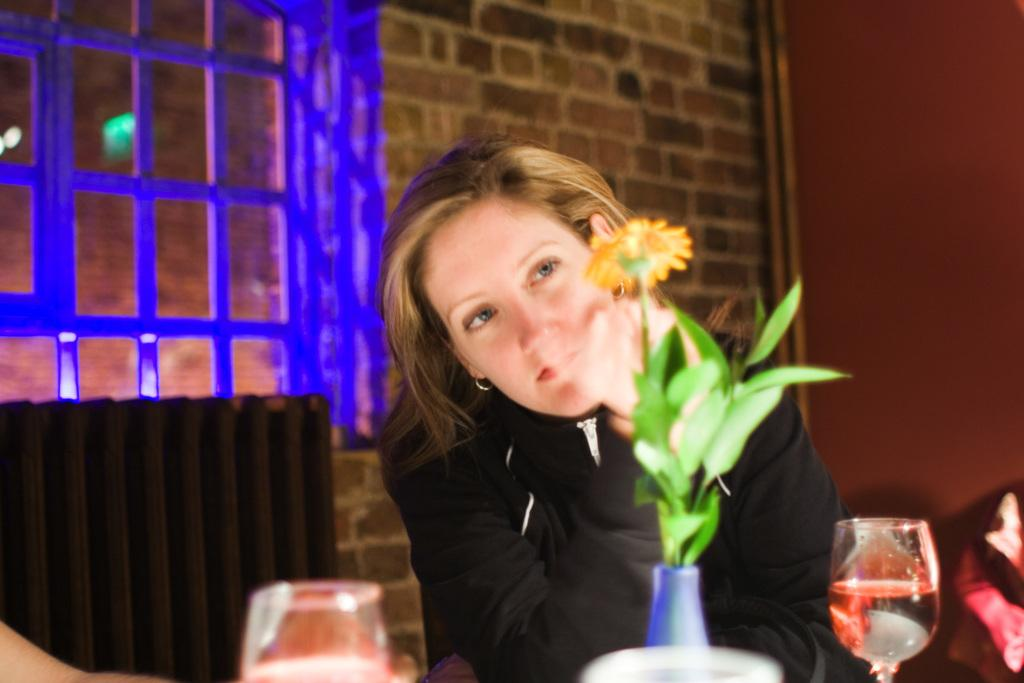What is the person in the image doing? The person is sitting on a chair in the image. What is in front of the person? There is a flower vase in front of the person. What can be seen on the object in front of the person? There are glasses on an object in front of the person. What is visible behind the person? There are windows and a wall visible behind the person. What type of competition is the person participating in while sitting on the chair? There is no indication of a competition in the image; the person is simply sitting on a chair. How does the person roll on the chair in the image? The person is not rolling on the chair in the image; they are sitting on it. 